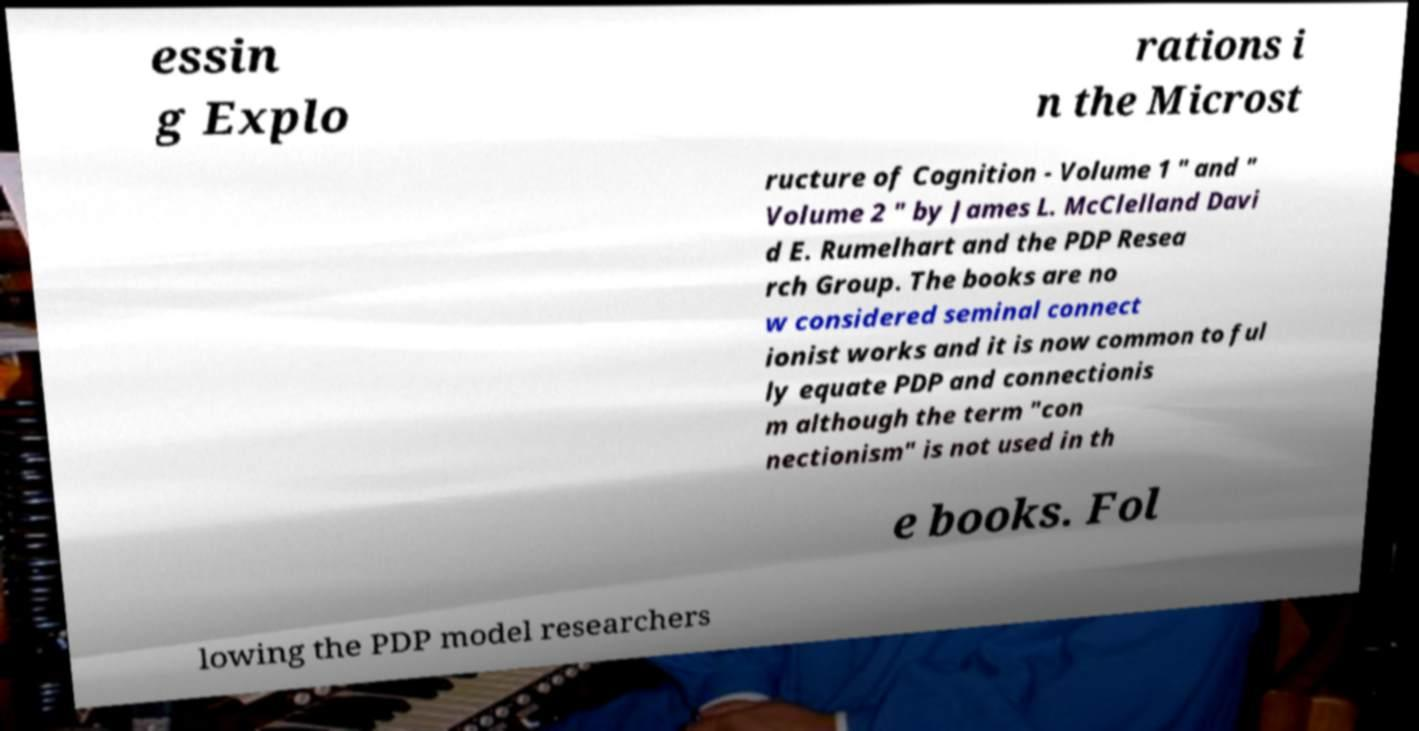Could you extract and type out the text from this image? essin g Explo rations i n the Microst ructure of Cognition - Volume 1 " and " Volume 2 " by James L. McClelland Davi d E. Rumelhart and the PDP Resea rch Group. The books are no w considered seminal connect ionist works and it is now common to ful ly equate PDP and connectionis m although the term "con nectionism" is not used in th e books. Fol lowing the PDP model researchers 